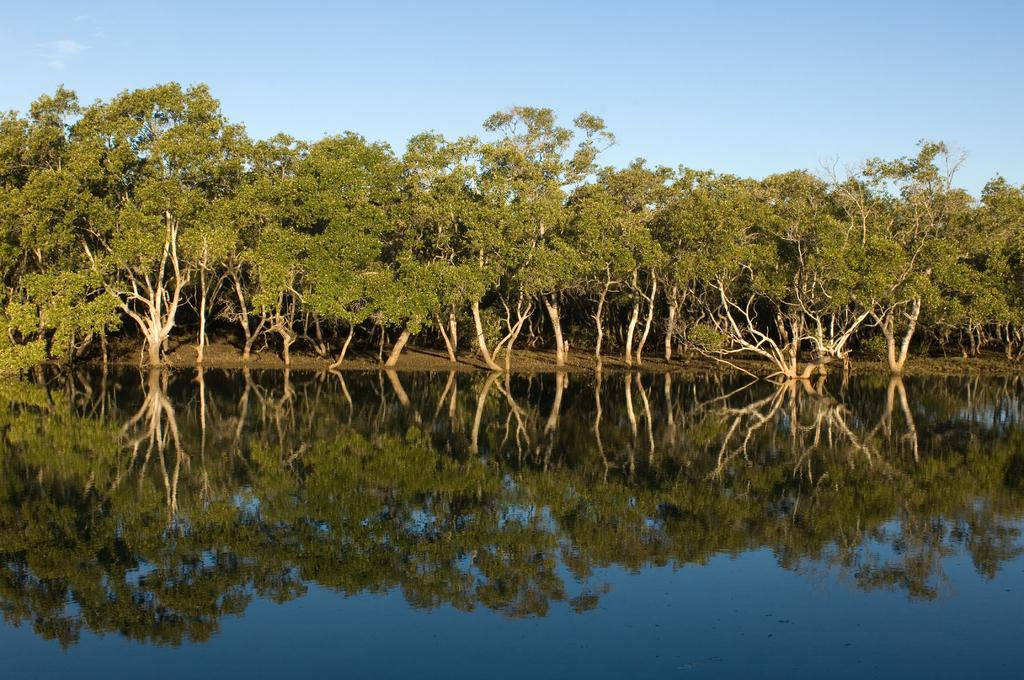What type of vegetation can be seen in the image? There are trees in the image. What natural element is visible besides the trees? There is water visible in the image. What is visible at the top of the image? The sky is visible at the top of the image. How many boards can be seen floating on the water in the image? There are no boards visible in the image; it only features trees, water, and the sky. What type of wood is used to construct the trees in the image? The type of wood used to construct the trees in the image cannot be determined from the image itself. 